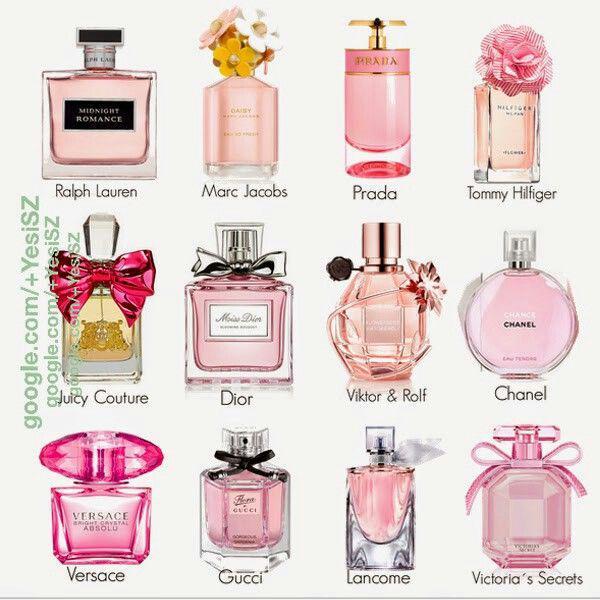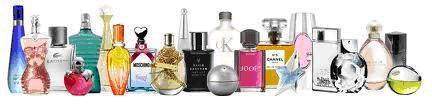The first image is the image on the left, the second image is the image on the right. Given the left and right images, does the statement "Both images show more than a dozen different perfume bottles, with a wide variety of colors, shapes, and sizes represented." hold true? Answer yes or no. No. The first image is the image on the left, the second image is the image on the right. For the images shown, is this caption "One of the images contains a single brand." true? Answer yes or no. No. 